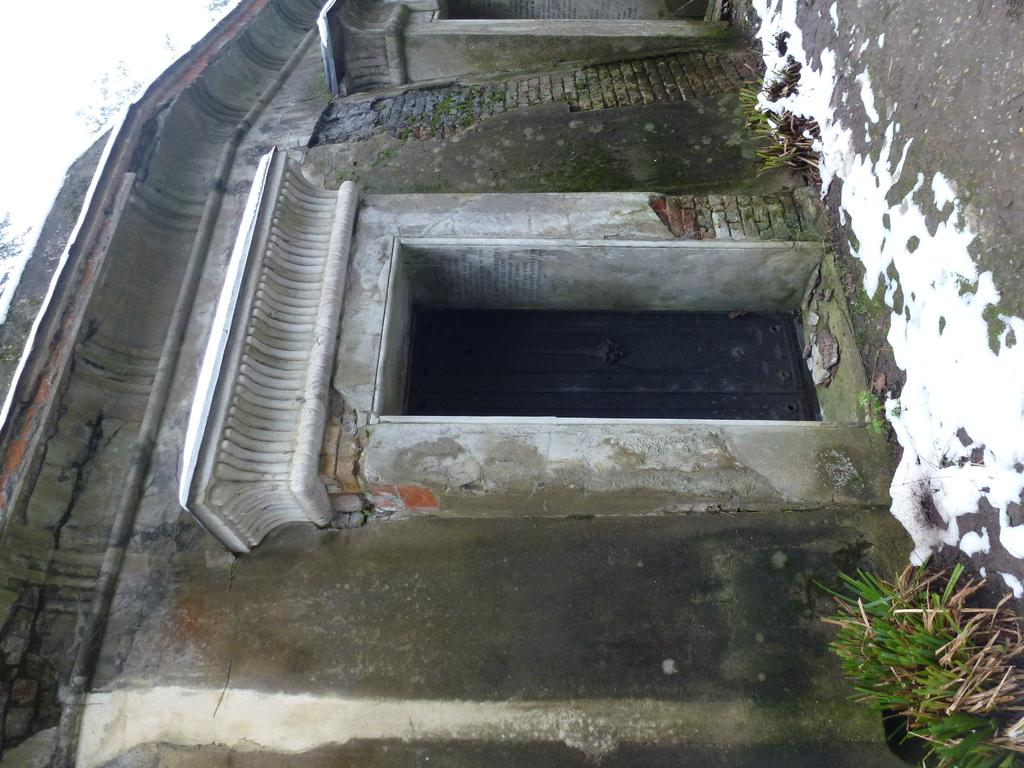What type of structure is visible in the image? There is a building in the image. Where is the building located in relation to the scene? The building is in front of the scene. What type of vegetation can be seen on the right side of the image? There are plants on the right side of the image. What is the condition of the ground in the image? There is snow on the ground in the image. What type of glass is used to make the boats in the image? There are no boats present in the image, so there is no glass used for making boats. 